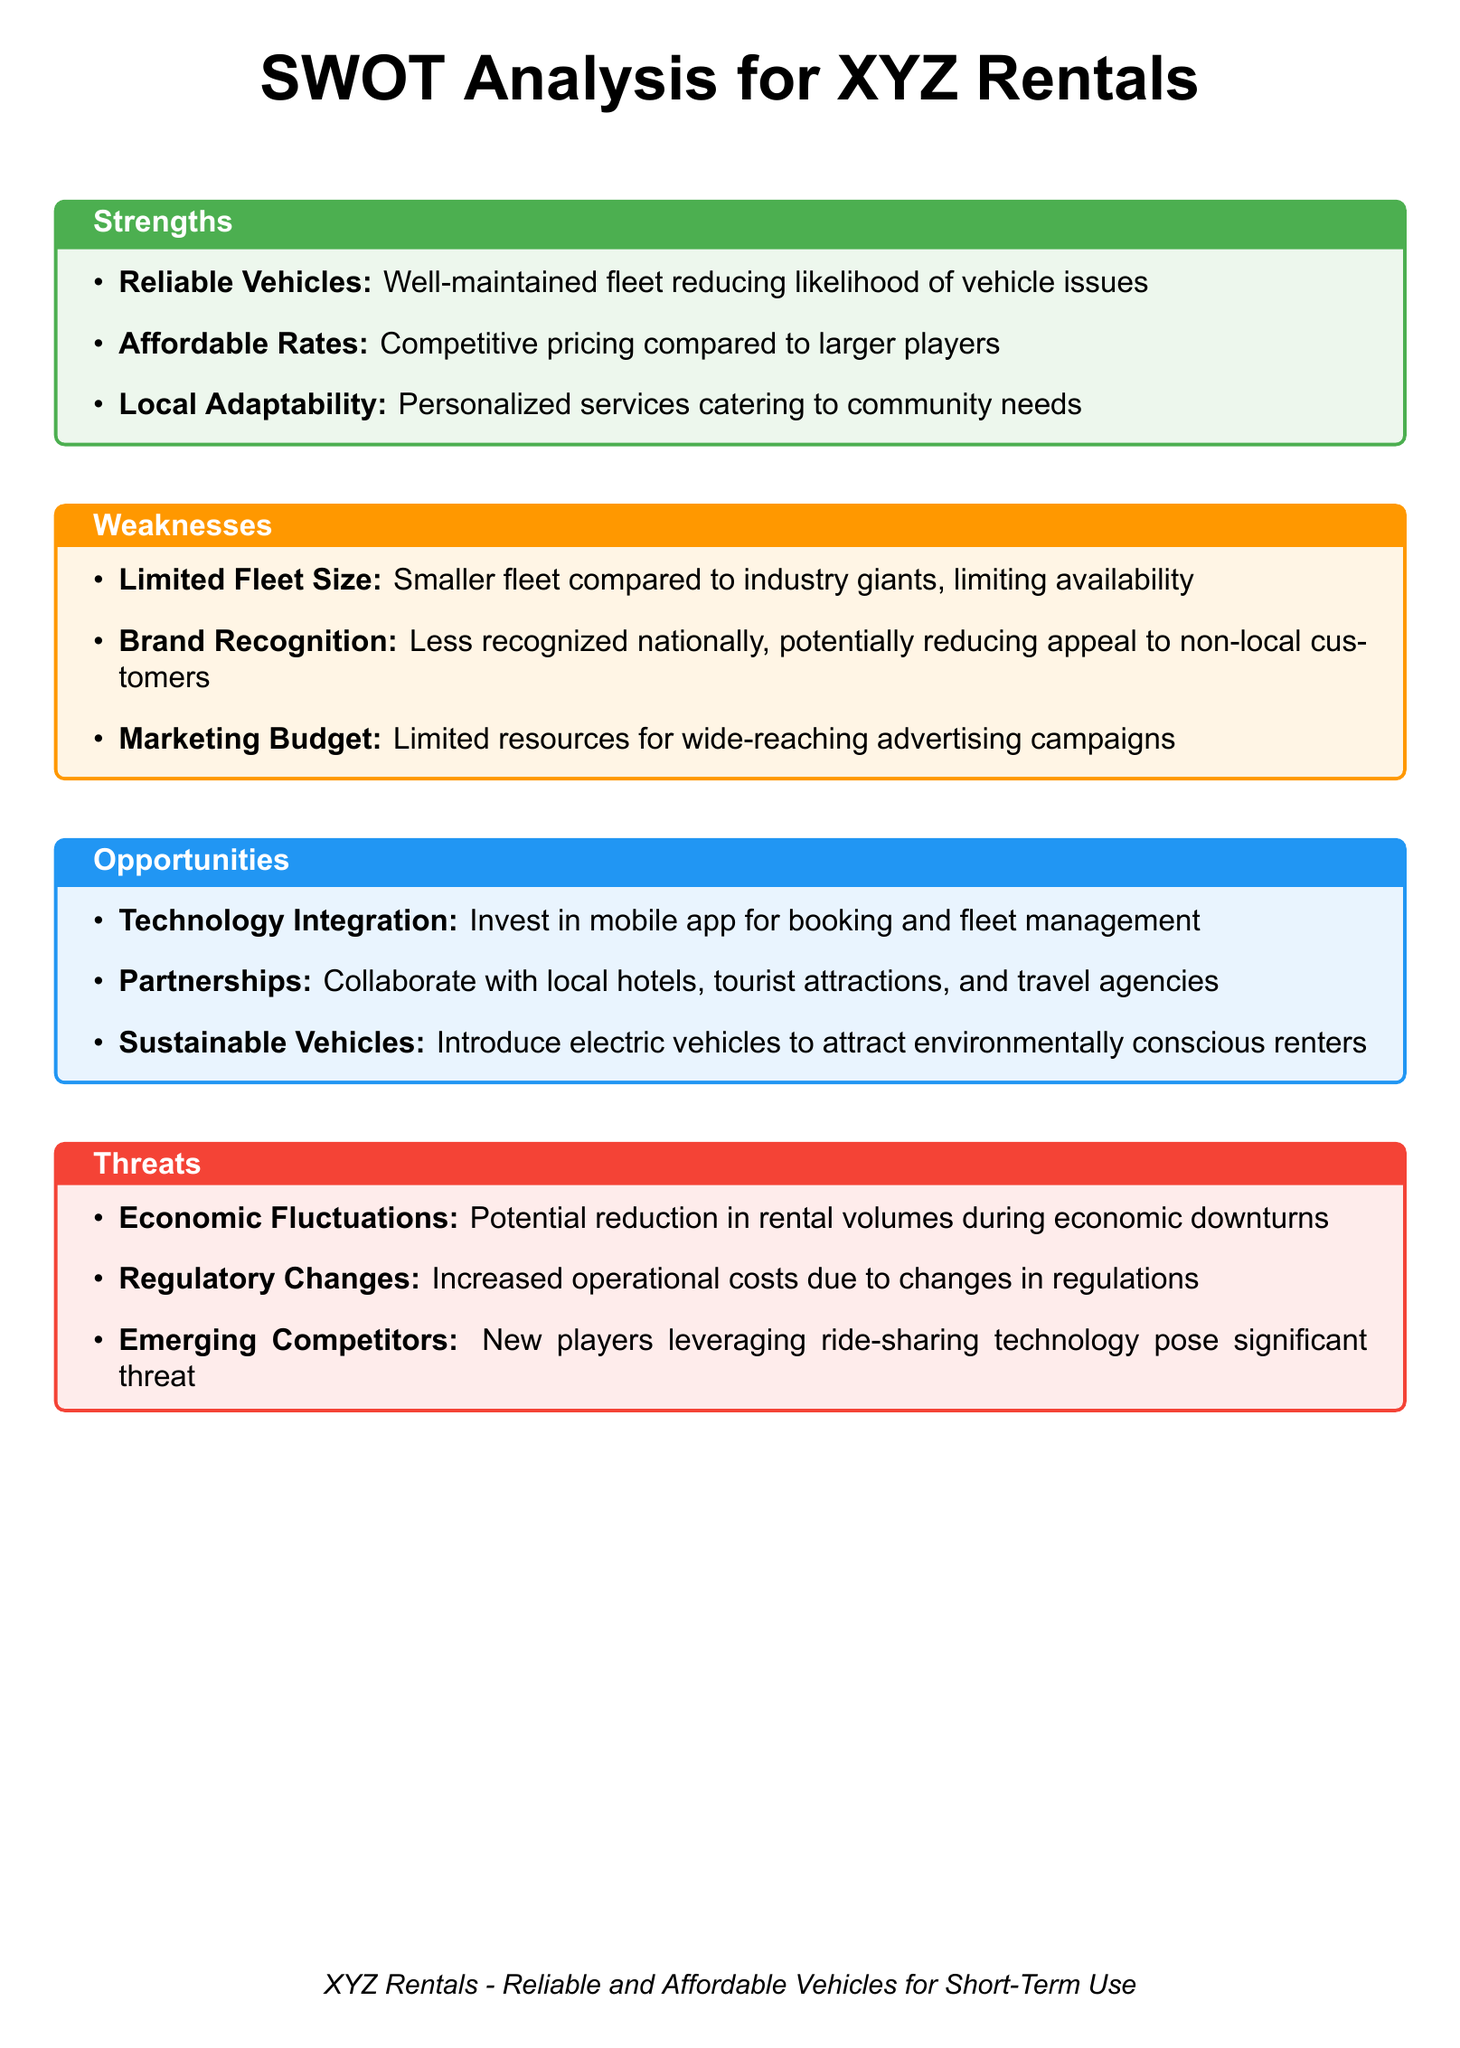What is the primary service offered by XYZ Rentals? The primary service is reliable and affordable vehicles for short-term use.
Answer: reliable and affordable vehicles for short-term use What is one key strength of XYZ Rentals? Strengths include well-maintained vehicles which reduce the likelihood of issues.
Answer: Reliable Vehicles What is a listed weakness regarding the fleet? One weakness is the smaller fleet size compared to industry giants.
Answer: Limited Fleet Size What opportunity involves technology for XYZ Rentals? An opportunity includes investing in a mobile app for booking and fleet management.
Answer: Technology Integration What significant threat could affect rental volumes? A significant threat is potential reduction in rental volumes during economic downturns.
Answer: Economic Fluctuations How does XYZ Rentals position itself against larger competitors? XYZ Rentals competes with affordable rates compared to larger players.
Answer: Affordable Rates Which aspect relates to customer engagement with local entities? One opportunity includes collaborating with local hotels, tourist attractions, and travel agencies.
Answer: Partnerships What is an example of a modern vehicle type that could be introduced? An example is introducing electric vehicles to attract environmentally conscious renters.
Answer: Electric Vehicles What factor limits XYZ Rentals' market reach? A key limiting factor is the brand recognition being less recognized nationally.
Answer: Brand Recognition 